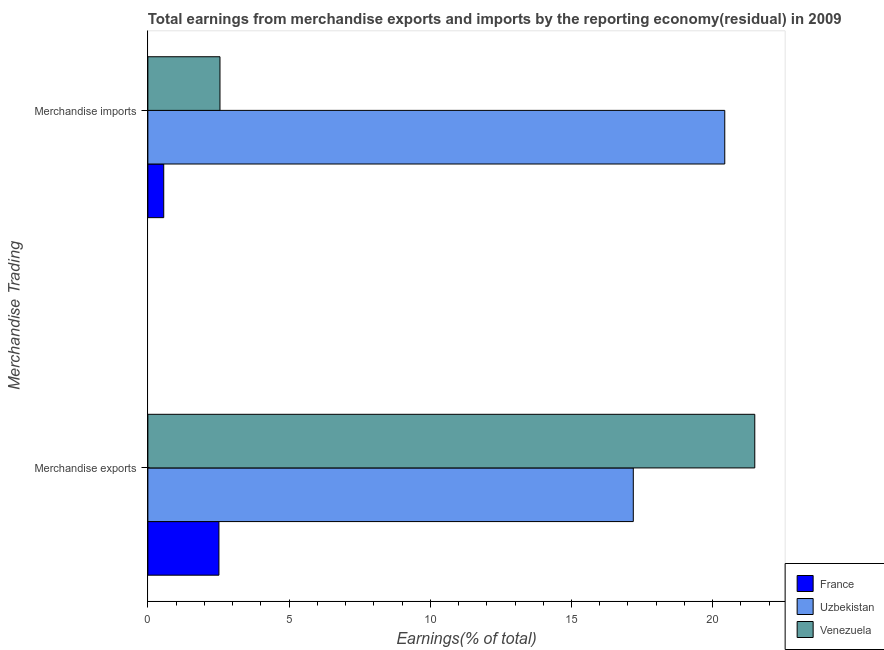How many different coloured bars are there?
Your answer should be very brief. 3. How many groups of bars are there?
Provide a short and direct response. 2. Are the number of bars per tick equal to the number of legend labels?
Keep it short and to the point. Yes. How many bars are there on the 1st tick from the bottom?
Provide a succinct answer. 3. What is the label of the 2nd group of bars from the top?
Keep it short and to the point. Merchandise exports. What is the earnings from merchandise exports in Venezuela?
Give a very brief answer. 21.49. Across all countries, what is the maximum earnings from merchandise imports?
Provide a succinct answer. 20.43. Across all countries, what is the minimum earnings from merchandise imports?
Ensure brevity in your answer.  0.56. In which country was the earnings from merchandise exports maximum?
Provide a succinct answer. Venezuela. What is the total earnings from merchandise exports in the graph?
Keep it short and to the point. 41.19. What is the difference between the earnings from merchandise exports in Venezuela and that in Uzbekistan?
Keep it short and to the point. 4.3. What is the difference between the earnings from merchandise imports in Venezuela and the earnings from merchandise exports in France?
Keep it short and to the point. 0.04. What is the average earnings from merchandise exports per country?
Offer a very short reply. 13.73. What is the difference between the earnings from merchandise imports and earnings from merchandise exports in Venezuela?
Your response must be concise. -18.94. What is the ratio of the earnings from merchandise imports in Venezuela to that in France?
Ensure brevity in your answer.  4.54. In how many countries, is the earnings from merchandise imports greater than the average earnings from merchandise imports taken over all countries?
Your answer should be very brief. 1. What does the 2nd bar from the top in Merchandise imports represents?
Make the answer very short. Uzbekistan. What does the 2nd bar from the bottom in Merchandise imports represents?
Offer a terse response. Uzbekistan. How many bars are there?
Make the answer very short. 6. How many countries are there in the graph?
Provide a succinct answer. 3. Are the values on the major ticks of X-axis written in scientific E-notation?
Offer a very short reply. No. Does the graph contain any zero values?
Your response must be concise. No. Does the graph contain grids?
Keep it short and to the point. No. How many legend labels are there?
Give a very brief answer. 3. How are the legend labels stacked?
Make the answer very short. Vertical. What is the title of the graph?
Offer a very short reply. Total earnings from merchandise exports and imports by the reporting economy(residual) in 2009. What is the label or title of the X-axis?
Your response must be concise. Earnings(% of total). What is the label or title of the Y-axis?
Make the answer very short. Merchandise Trading. What is the Earnings(% of total) in France in Merchandise exports?
Offer a very short reply. 2.52. What is the Earnings(% of total) in Uzbekistan in Merchandise exports?
Offer a very short reply. 17.19. What is the Earnings(% of total) in Venezuela in Merchandise exports?
Keep it short and to the point. 21.49. What is the Earnings(% of total) of France in Merchandise imports?
Make the answer very short. 0.56. What is the Earnings(% of total) in Uzbekistan in Merchandise imports?
Ensure brevity in your answer.  20.43. What is the Earnings(% of total) of Venezuela in Merchandise imports?
Provide a short and direct response. 2.55. Across all Merchandise Trading, what is the maximum Earnings(% of total) of France?
Offer a very short reply. 2.52. Across all Merchandise Trading, what is the maximum Earnings(% of total) of Uzbekistan?
Offer a very short reply. 20.43. Across all Merchandise Trading, what is the maximum Earnings(% of total) of Venezuela?
Keep it short and to the point. 21.49. Across all Merchandise Trading, what is the minimum Earnings(% of total) in France?
Your answer should be very brief. 0.56. Across all Merchandise Trading, what is the minimum Earnings(% of total) in Uzbekistan?
Offer a very short reply. 17.19. Across all Merchandise Trading, what is the minimum Earnings(% of total) of Venezuela?
Your answer should be compact. 2.55. What is the total Earnings(% of total) of France in the graph?
Offer a terse response. 3.08. What is the total Earnings(% of total) of Uzbekistan in the graph?
Your answer should be very brief. 37.61. What is the total Earnings(% of total) in Venezuela in the graph?
Your response must be concise. 24.04. What is the difference between the Earnings(% of total) in France in Merchandise exports and that in Merchandise imports?
Keep it short and to the point. 1.95. What is the difference between the Earnings(% of total) in Uzbekistan in Merchandise exports and that in Merchandise imports?
Your response must be concise. -3.24. What is the difference between the Earnings(% of total) of Venezuela in Merchandise exports and that in Merchandise imports?
Make the answer very short. 18.94. What is the difference between the Earnings(% of total) of France in Merchandise exports and the Earnings(% of total) of Uzbekistan in Merchandise imports?
Offer a terse response. -17.91. What is the difference between the Earnings(% of total) of France in Merchandise exports and the Earnings(% of total) of Venezuela in Merchandise imports?
Make the answer very short. -0.04. What is the difference between the Earnings(% of total) in Uzbekistan in Merchandise exports and the Earnings(% of total) in Venezuela in Merchandise imports?
Your response must be concise. 14.63. What is the average Earnings(% of total) in France per Merchandise Trading?
Give a very brief answer. 1.54. What is the average Earnings(% of total) of Uzbekistan per Merchandise Trading?
Provide a short and direct response. 18.81. What is the average Earnings(% of total) in Venezuela per Merchandise Trading?
Your response must be concise. 12.02. What is the difference between the Earnings(% of total) in France and Earnings(% of total) in Uzbekistan in Merchandise exports?
Your answer should be compact. -14.67. What is the difference between the Earnings(% of total) of France and Earnings(% of total) of Venezuela in Merchandise exports?
Offer a very short reply. -18.97. What is the difference between the Earnings(% of total) of Uzbekistan and Earnings(% of total) of Venezuela in Merchandise exports?
Provide a short and direct response. -4.3. What is the difference between the Earnings(% of total) in France and Earnings(% of total) in Uzbekistan in Merchandise imports?
Your answer should be very brief. -19.86. What is the difference between the Earnings(% of total) in France and Earnings(% of total) in Venezuela in Merchandise imports?
Offer a very short reply. -1.99. What is the difference between the Earnings(% of total) of Uzbekistan and Earnings(% of total) of Venezuela in Merchandise imports?
Make the answer very short. 17.87. What is the ratio of the Earnings(% of total) of France in Merchandise exports to that in Merchandise imports?
Your response must be concise. 4.48. What is the ratio of the Earnings(% of total) in Uzbekistan in Merchandise exports to that in Merchandise imports?
Give a very brief answer. 0.84. What is the ratio of the Earnings(% of total) of Venezuela in Merchandise exports to that in Merchandise imports?
Your answer should be compact. 8.42. What is the difference between the highest and the second highest Earnings(% of total) of France?
Provide a short and direct response. 1.95. What is the difference between the highest and the second highest Earnings(% of total) in Uzbekistan?
Keep it short and to the point. 3.24. What is the difference between the highest and the second highest Earnings(% of total) of Venezuela?
Give a very brief answer. 18.94. What is the difference between the highest and the lowest Earnings(% of total) of France?
Your response must be concise. 1.95. What is the difference between the highest and the lowest Earnings(% of total) of Uzbekistan?
Ensure brevity in your answer.  3.24. What is the difference between the highest and the lowest Earnings(% of total) in Venezuela?
Keep it short and to the point. 18.94. 